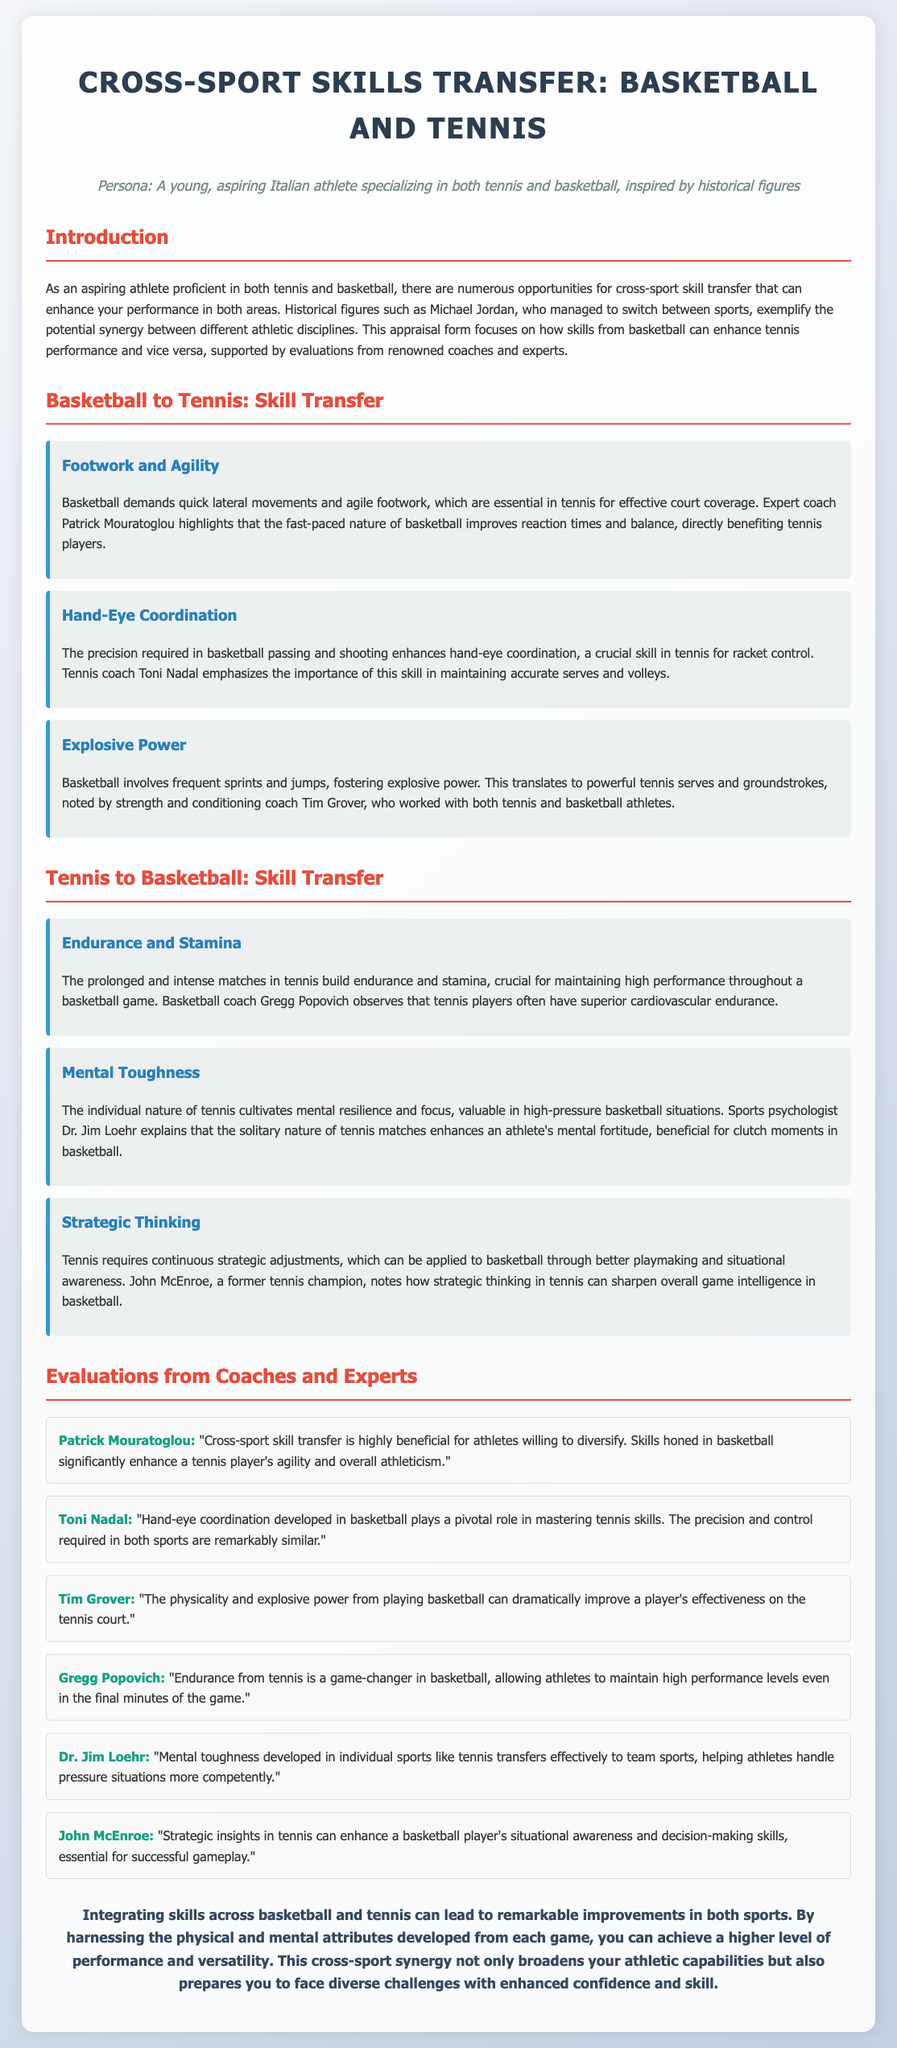What is the primary focus of the appraisal form? The document focuses on how skills from basketball enhance tennis performance and vice versa.
Answer: Cross-sport skill transfer Who is a notable historical figure mentioned in the document? The document cites Michael Jordan as an example of successful cross-sport talent.
Answer: Michael Jordan Which skill from basketball is said to enhance footwork in tennis? Footwork and agility are highlighted as transferable skills from basketball to tennis.
Answer: Footwork and agility Who emphasizes the importance of hand-eye coordination in tennis? Toni Nadal is mentioned as emphasizing the importance of hand-eye coordination.
Answer: Toni Nadal What physical benefit from basketball is noted to improve tennis serves? Explosive power developed in basketball translates to more powerful tennis serves.
Answer: Explosive power What aspect of tennis builds endurance for basketball players? The prolonged and intense matches in tennis build endurance.
Answer: Endurance Which coach highlights the significance of mental toughness from tennis? Dr. Jim Loehr explains that mental toughness from tennis aids performance in basketball.
Answer: Dr. Jim Loehr What strategic concept from tennis can benefit basketball gameplay? Strategic thinking in tennis can enhance playmaking in basketball.
Answer: Strategic thinking How do basketball coaches view the impact of tennis on performance? Basketball coach Gregg Popovich observes that tennis players often have superior cardiovascular endurance.
Answer: Superior cardiovascular endurance 